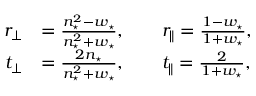<formula> <loc_0><loc_0><loc_500><loc_500>\begin{array} { r l } { r _ { \perp } } & { = \frac { n _ { ^ { * } } ^ { 2 } - w _ { ^ { * } } } { n _ { ^ { * } } ^ { 2 } + w _ { ^ { * } } } , \quad r _ { \| } = \frac { 1 - w _ { ^ { * } } } { 1 + w _ { ^ { * } } } , } \\ { t _ { \perp } } & { = \frac { 2 n _ { ^ { * } } } { n _ { ^ { * } } ^ { 2 } + w _ { ^ { * } } } , \quad t _ { \| } = \frac { 2 } { 1 + w _ { ^ { * } } } , } \end{array}</formula> 